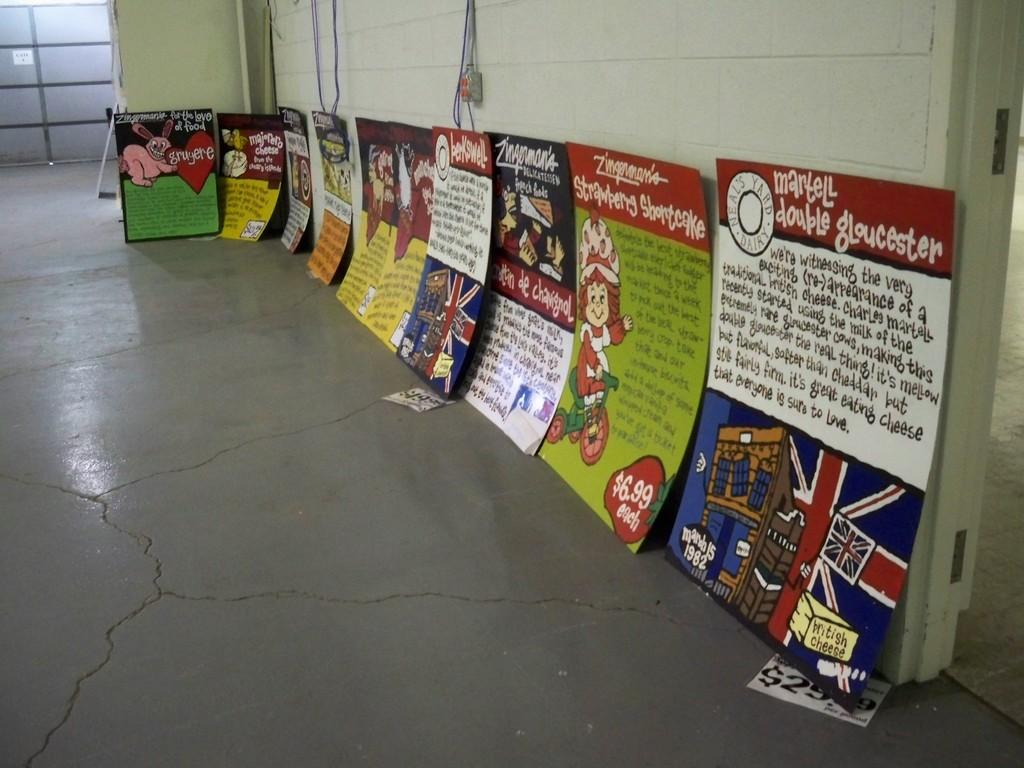<image>
Relay a brief, clear account of the picture shown. several posters are lining a wall including a strawberry shortcake one 